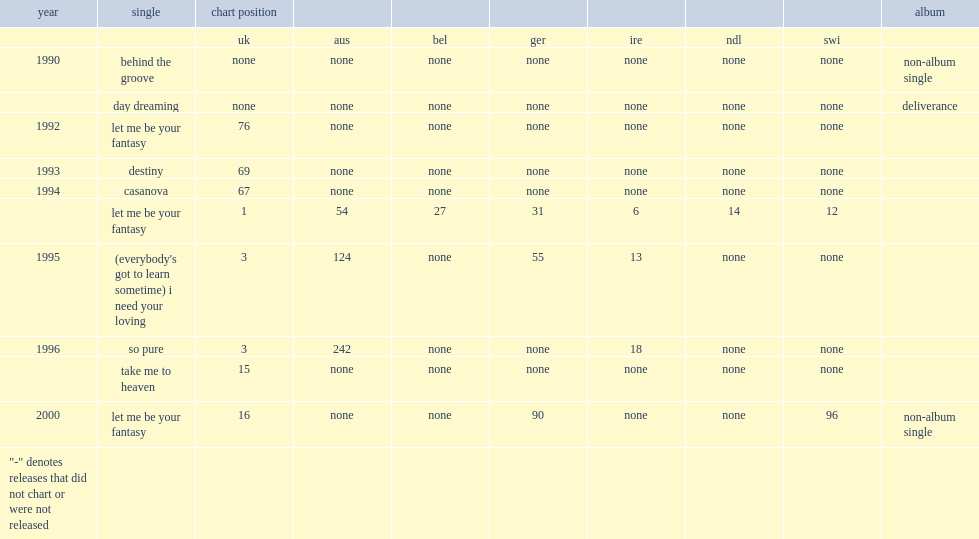When did the single (everybody's got to learn sometime) release? 1995.0. 